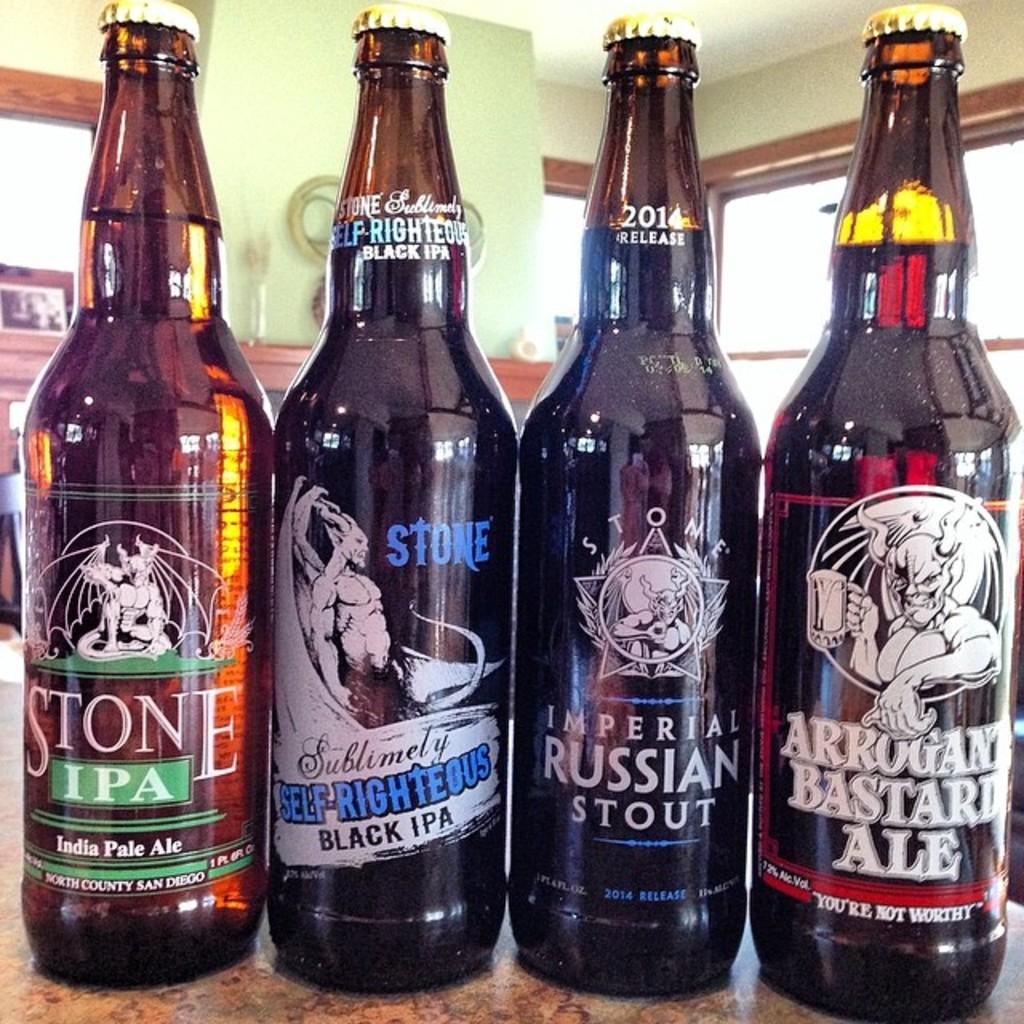What brewery is represented by these beverages?
Provide a short and direct response. Stone. 